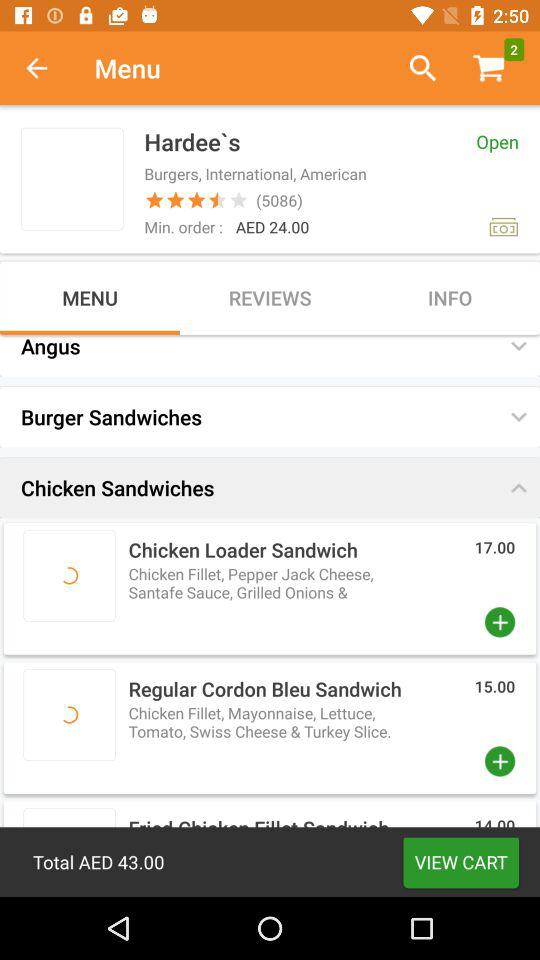How many items are in the shopping cart?
Answer the question using a single word or phrase. 2 